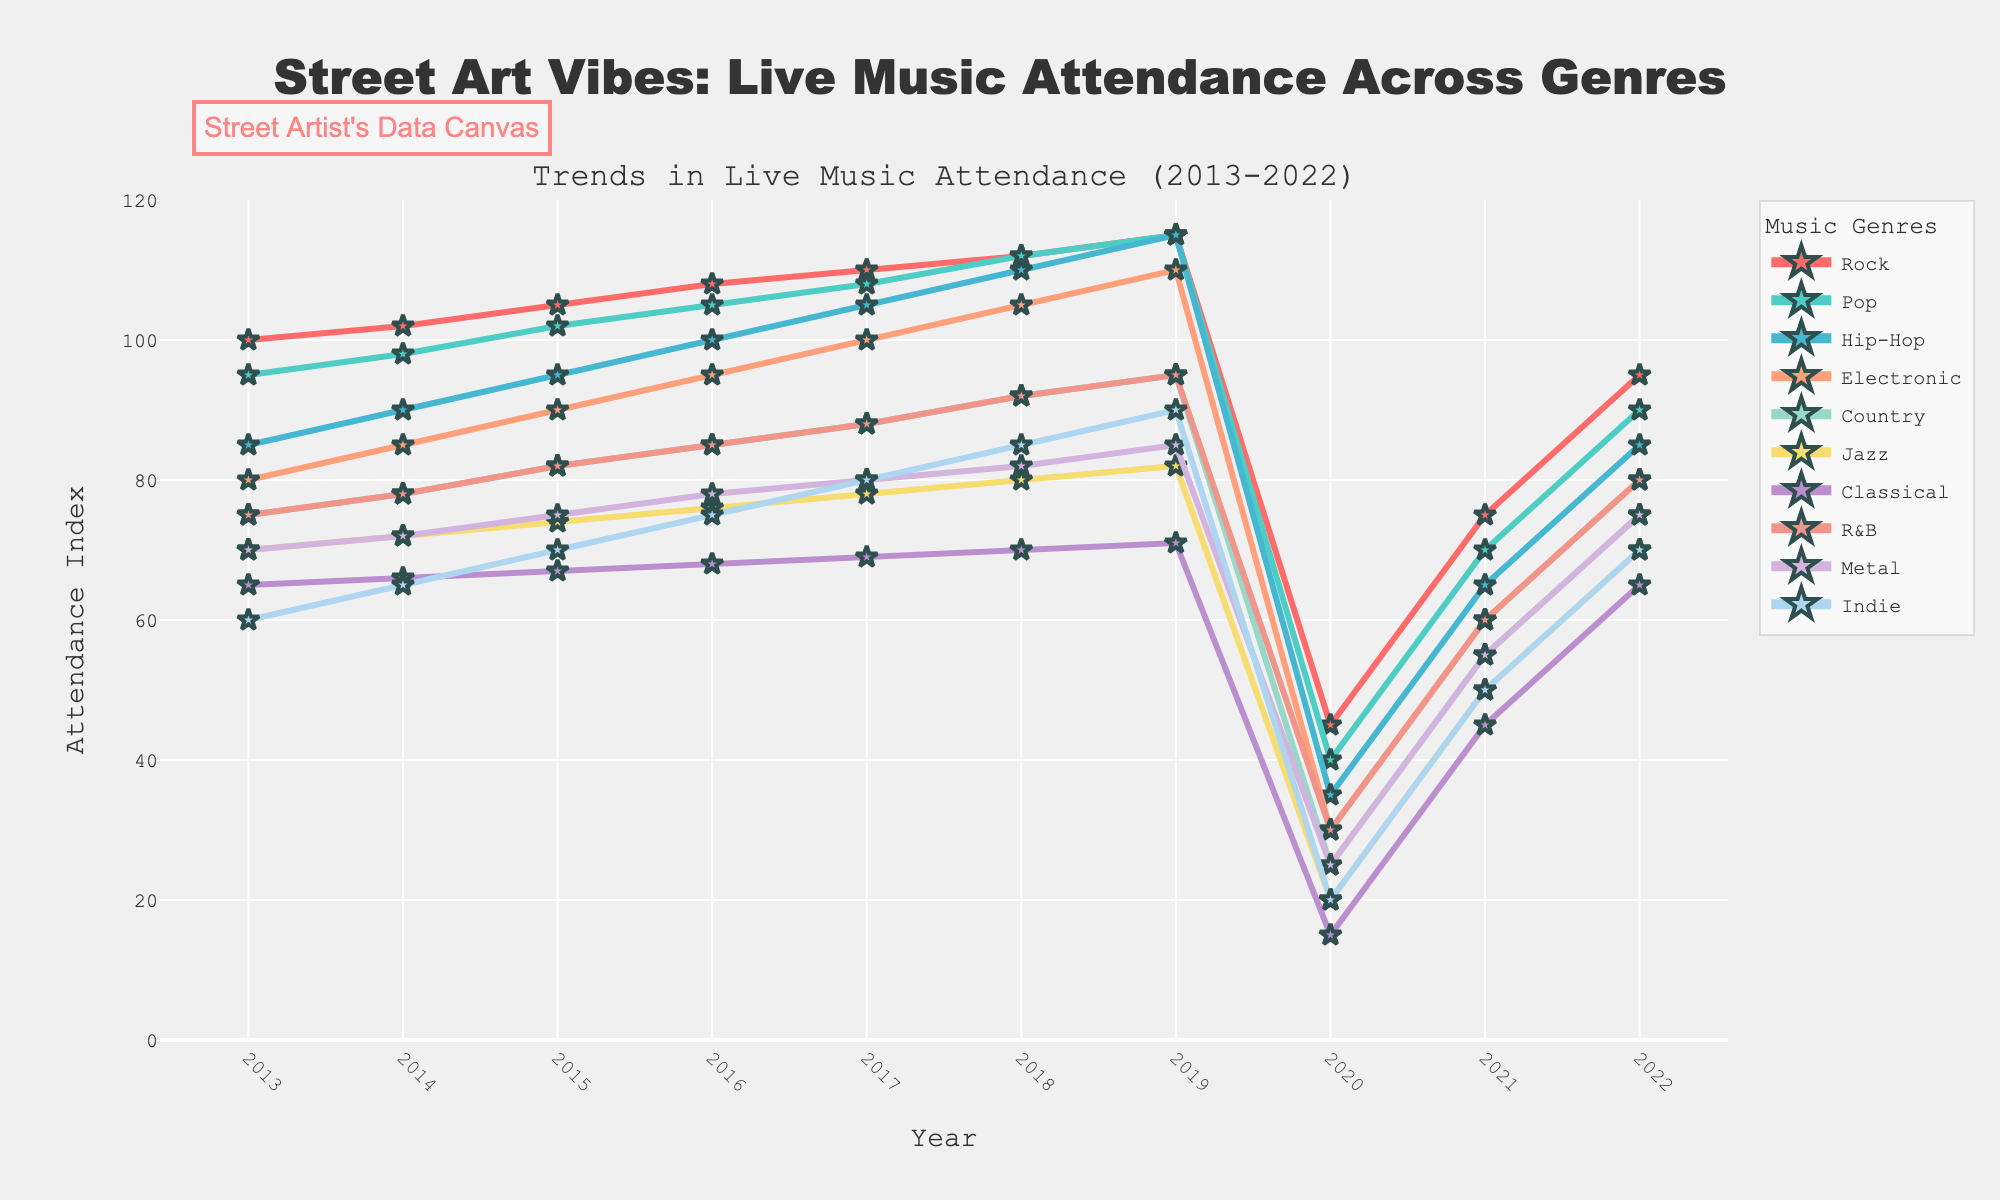What was the attendance index for Rock music in 2020? Look at the point corresponding to the year 2020 on the Rock music line marked in the figure.
Answer: 45 Which genre had the lowest attendance index in 2013? Locate the lowest data point among all genres for the year 2013 on the left side of the figure.
Answer: Indie How did the attendance for Pop music change from 2017 to 2021? Calculate the difference by subtracting the attendance index in 2021 from that in 2017 for Pop music.
Answer: -38 Which genre had the most significant drop in attendance between 2019 and 2020? Compare the drop in attendance for all genres between 2019 and 2020 by finding the steepest decline on the graph.
Answer: Hip-Hop What is the average attendance index for Classical music over the decade? Add up the attendance indices for Classical music from 2013 to 2022 and divide by the total number of years (10).
Answer: 60 Between Metal and Indie, which genre had a higher attendance index in 2019? Compare the data points for Metal and Indie in 2019 on the graph.
Answer: Metal Which genre had a consistent increase in attendance from 2013 to 2019 before dropping in 2020? Identify the genre with a steady upward trend from 2013 to 2019, followed by a decline in 2020.
Answer: Pop What was the overall trend in live music attendance for R&B from 2013 to 2022? Observe the line trend for R&B from 2013 to 2022, noting any periods of increase or decrease.
Answer: Increased, then dropped, then increased again Compare the attendance in 2022 across all genres. Which genre had the second highest attendance in 2022? Find the attendance values for the year 2022 across all genres and identify the second highest value.
Answer: Rock 